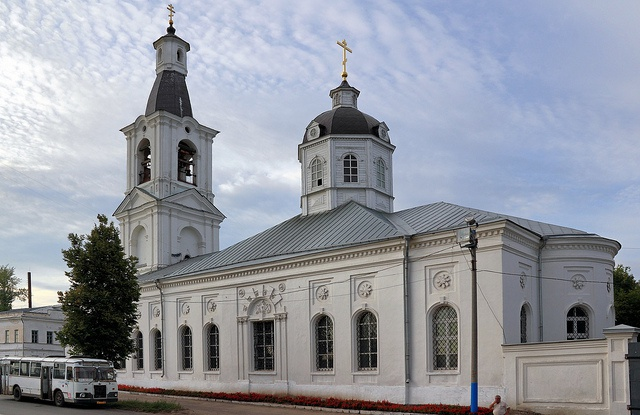Describe the objects in this image and their specific colors. I can see bus in lightgray, black, gray, and darkgray tones and people in lightgray, gray, maroon, and darkgray tones in this image. 